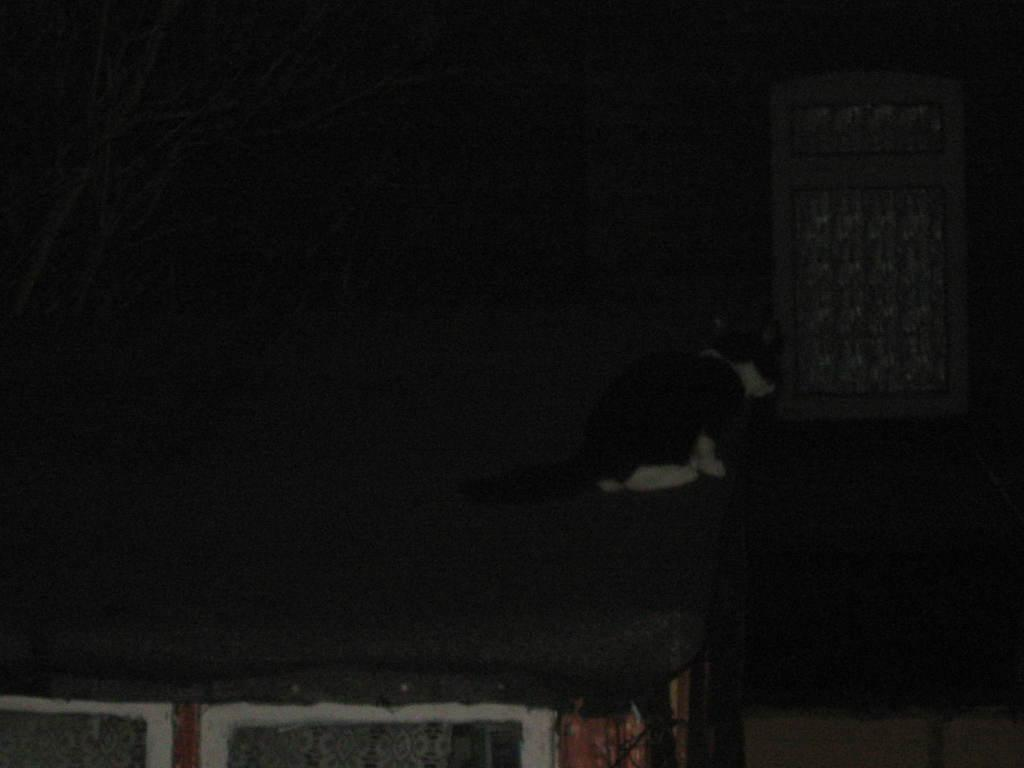What is the lighting condition in the room in the picture? The room in the picture is dark. What piece of furniture can be seen in the room? There is a table in the room. What type of animal is present in the room? There is a cat in the room. What colors does the cat have? The cat is white and black in color. What can be seen in the background of the room? There is a white door in the background of the room. Can you see any fog in the room? There is no mention of fog in the image, so it cannot be determined if it is present or not. How many kittens are playing with the cat in the room? There is no mention of kittens in the image; only one cat is present. 